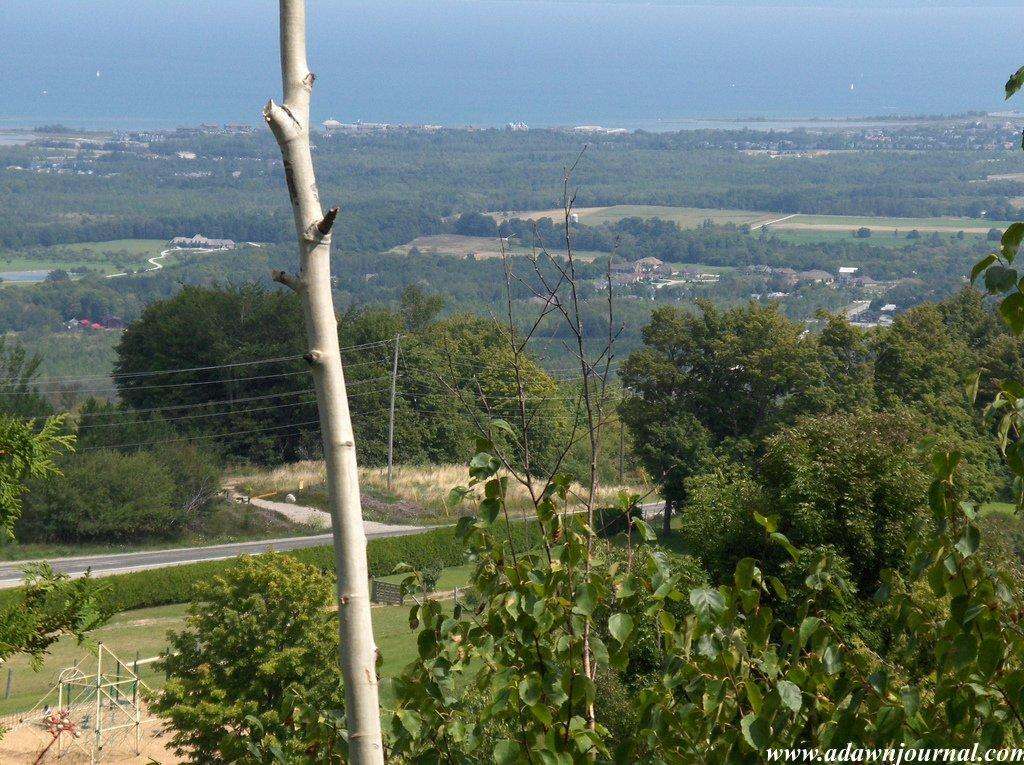What type of vegetation can be seen in the image? There are trees, bushes, and plants visible in the image. What is the ground like in the image? The ground is visible in the image. What is the main feature of the image? The main feature of the image is a grill. What else can be seen in the image besides the grill? There is a road, water, and the sky visible in the image. How do the boys show respect to the spring in the image? There are no boys or springs present in the image. 